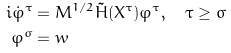Convert formula to latex. <formula><loc_0><loc_0><loc_500><loc_500>i \dot { \varphi } ^ { \tau } & = M ^ { 1 / 2 } \tilde { H } ( X ^ { \tau } ) \varphi ^ { \tau } , \quad \tau \geq \sigma \\ \varphi ^ { \sigma } & = w</formula> 